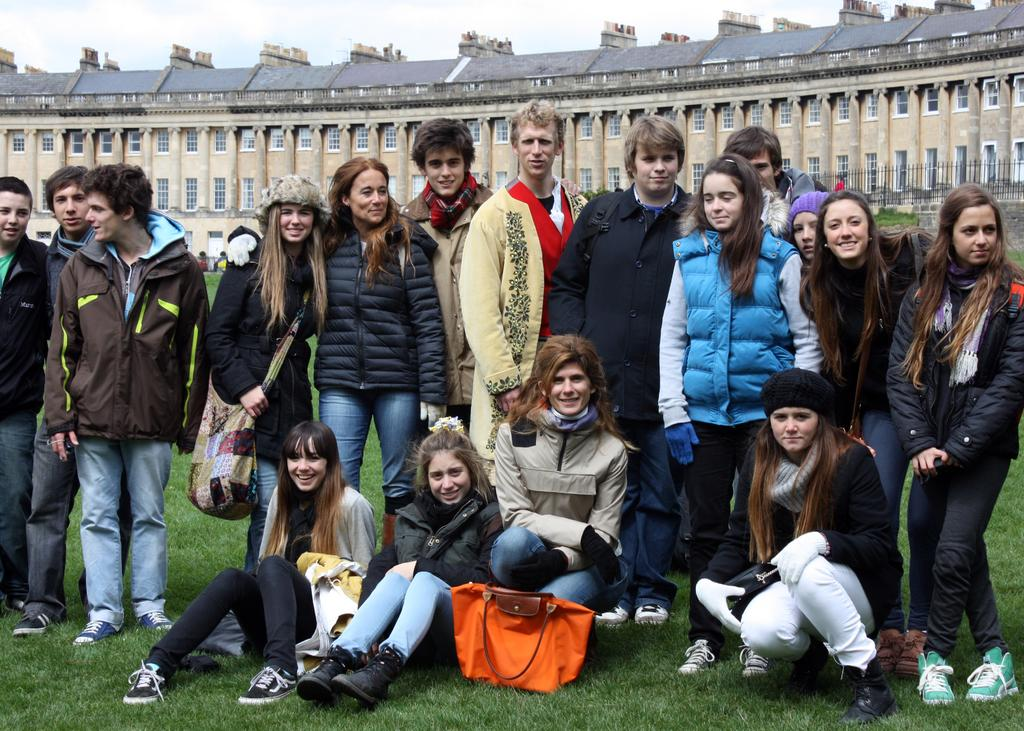How many people are in the image? There are multiple people in the image. What are some of the people in the image doing? Some people are sitting on the ground, while others are standing. What can be seen in the background of the image? There is a building and the sky visible in the background of the image. What type of wound can be seen on the representative in the image? There is no representative or wound present in the image. 